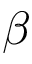Convert formula to latex. <formula><loc_0><loc_0><loc_500><loc_500>\beta</formula> 